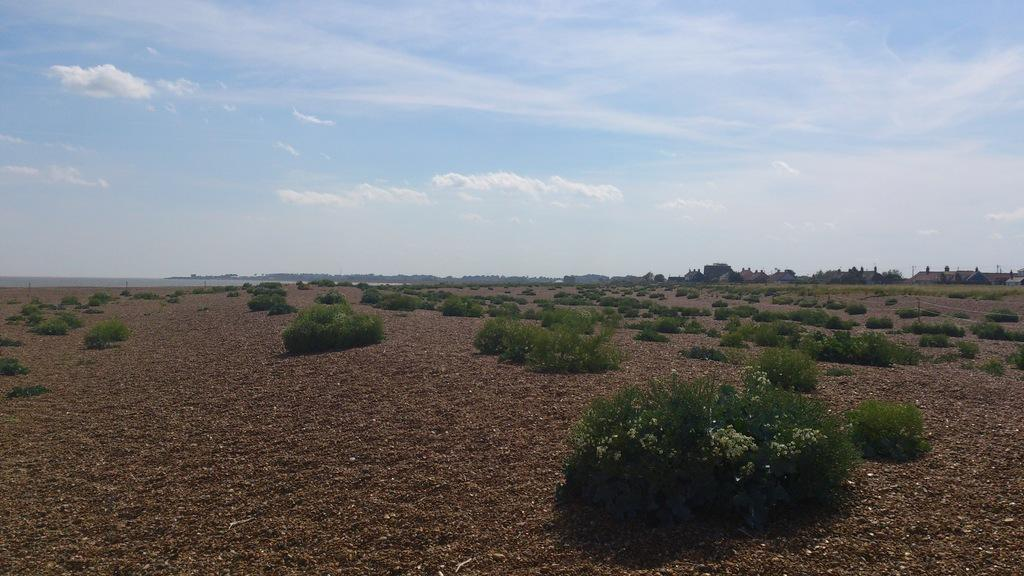What type of living organisms can be seen in the image? Plants can be seen in the image. What is on the floor in the image? There is soil on the floor in the image. What can be seen in the background of the image? Buildings and trees can be seen in the background of the image. What is the condition of the sky in the image? The sky is clear in the image. What type of butter can be seen in the image? There is no butter present in the image. 